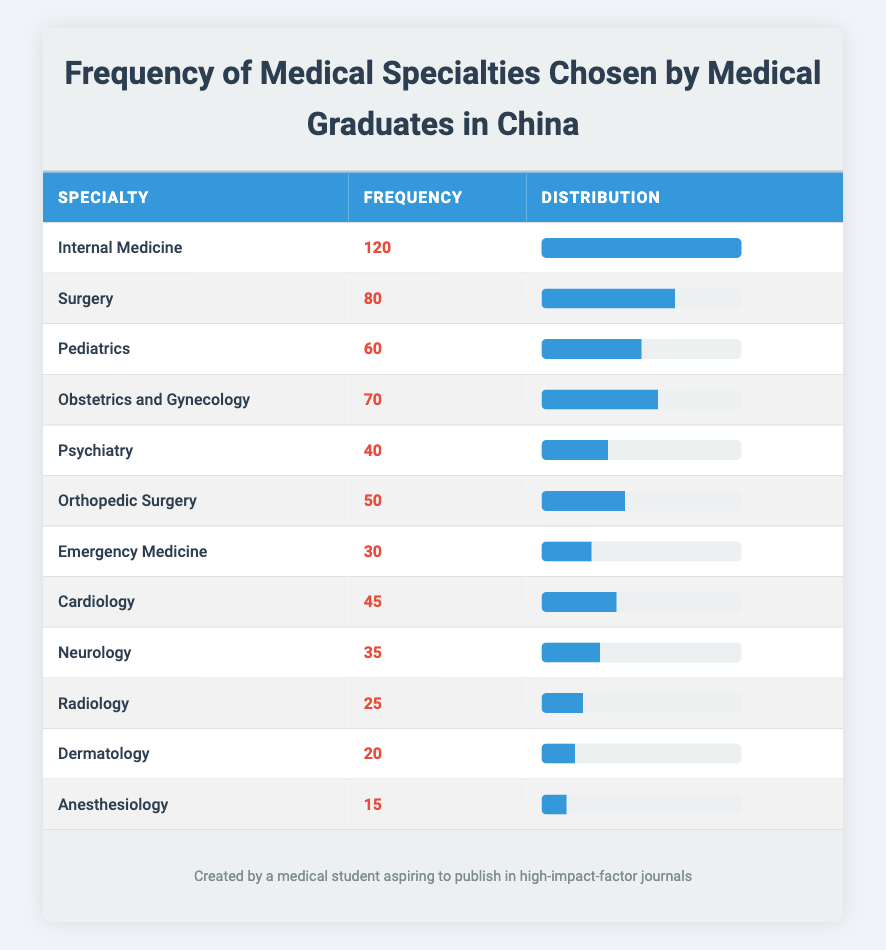What is the frequency of the Internal Medicine specialty? The table shows that the frequency for the Internal Medicine specialty is listed directly as 120.
Answer: 120 Which specialty has the lowest frequency? By looking at the frequency values in the table, the specialty with the lowest frequency is Anesthesiology, with a value of 15.
Answer: Anesthesiology What is the total frequency of all specialties combined? To find the total frequency, we sum all the frequencies: 120 + 80 + 60 + 70 + 40 + 50 + 30 + 45 + 35 + 25 + 20 + 15 =  570.
Answer: 570 How many more graduates chose Internal Medicine compared to Psychiatry? Internal Medicine has a frequency of 120, and Psychiatry has a frequency of 40. The difference is 120 - 40 = 80.
Answer: 80 Is the frequency of Surgery greater than both Cardiology and Neurology? Surgery has a frequency of 80. Cardiology has a frequency of 45 and Neurology has a frequency of 35. Since 80 > 45 and 80 > 35, Surgery's frequency is greater than both.
Answer: Yes What percentage of graduates chose Pediatrics? The frequency for Pediatrics is 60. To find the percentage, we calculate (60 / 570) * 100 = approximately 10.53%.
Answer: Approximately 10.53% Which specialty had a frequency that is more than double that of Emergency Medicine? Emergency Medicine has a frequency of 30. Therefore, more than double would be more than 60. The specialties with frequencies greater than 60 are Internal Medicine (120), Surgery (80), and Pediatrics (60).
Answer: Internal Medicine, Surgery What is the average frequency of the specialties listed? To find the average frequency, we sum all frequencies (which we calculated as 570) and divide by the number of specialties (12). So, the average is 570 / 12 = 47.5.
Answer: 47.5 Can we conclude that more graduates chose Obstetrics and Gynecology than Psychiatry? Obstetrics and Gynecology has a frequency of 70, while Psychiatry has a frequency of 40. Since 70 > 40, we conclude that more graduates chose Obstetrics and Gynecology.
Answer: Yes 